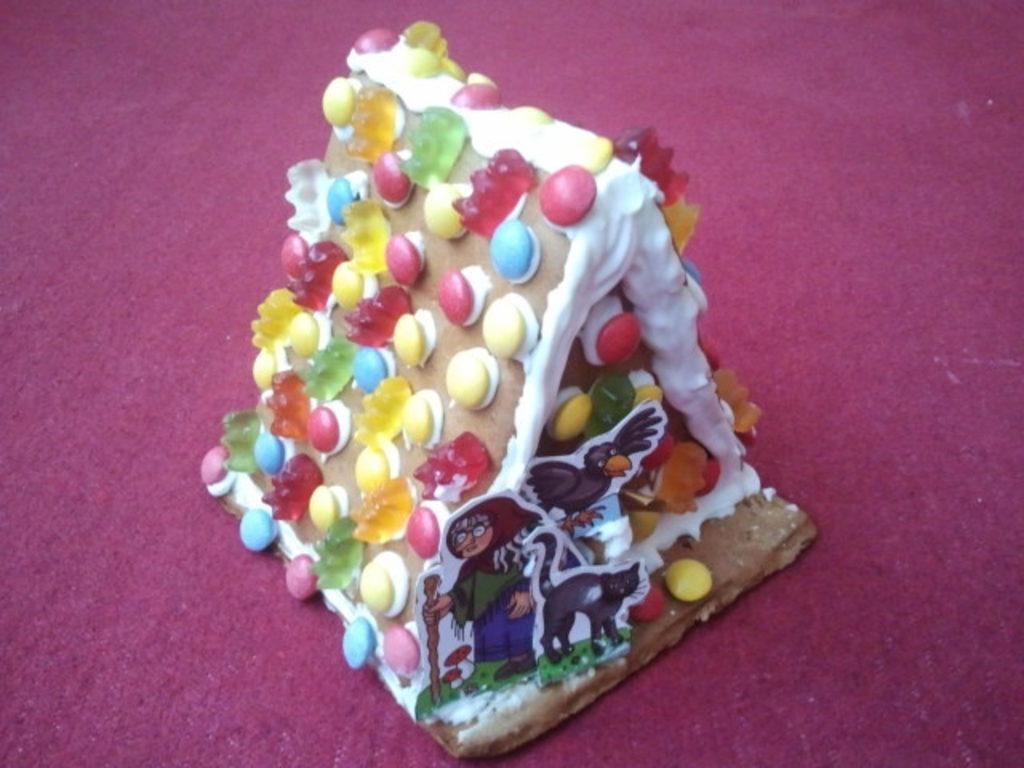In one or two sentences, can you explain what this image depicts? In this image we can see a cake placed on the surface. 